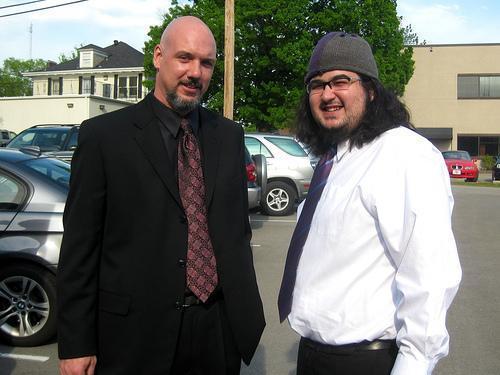How many ties are visible?
Give a very brief answer. 2. How many people are there?
Give a very brief answer. 2. How many cars are there?
Give a very brief answer. 3. How many tusks does the elephant have?
Give a very brief answer. 0. 